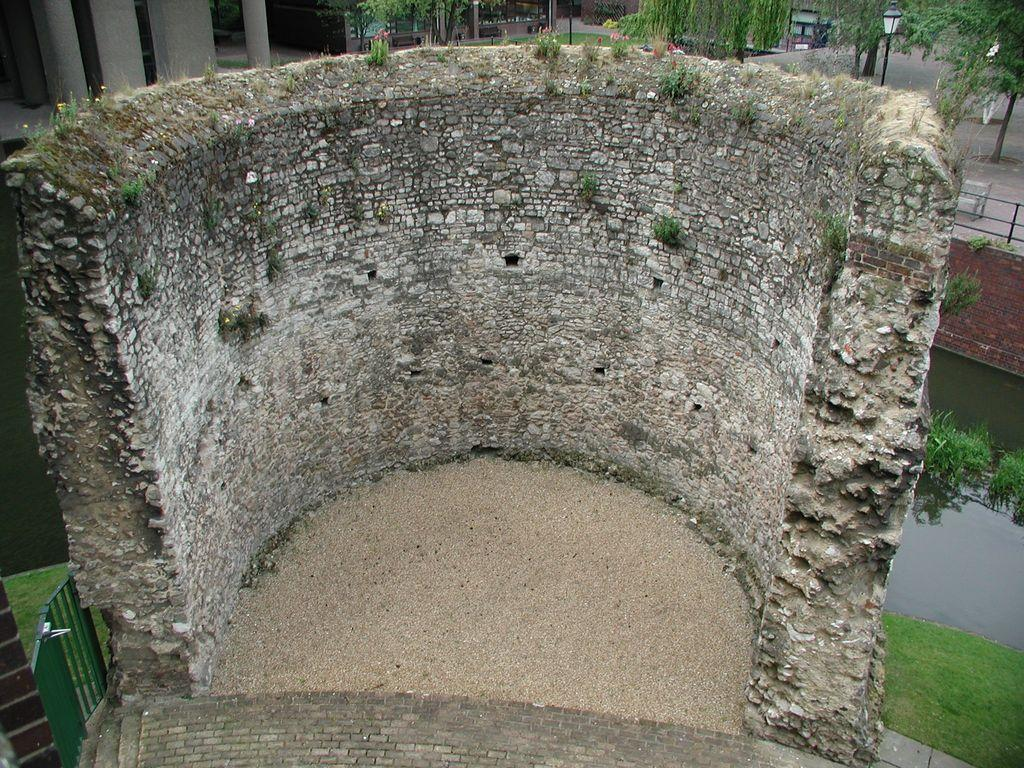What is the condition of the brick wall in the image? The brick wall in the image is half broken. What can be seen in the background of the image? There is a building, a pillar, trees, and street lights visible in the background of the image. What is present on the right side of the image? There is water and fencing visible on the right side of the image. Can you hear the birds laughing in the image? There are no birds or laughter present in the image. 